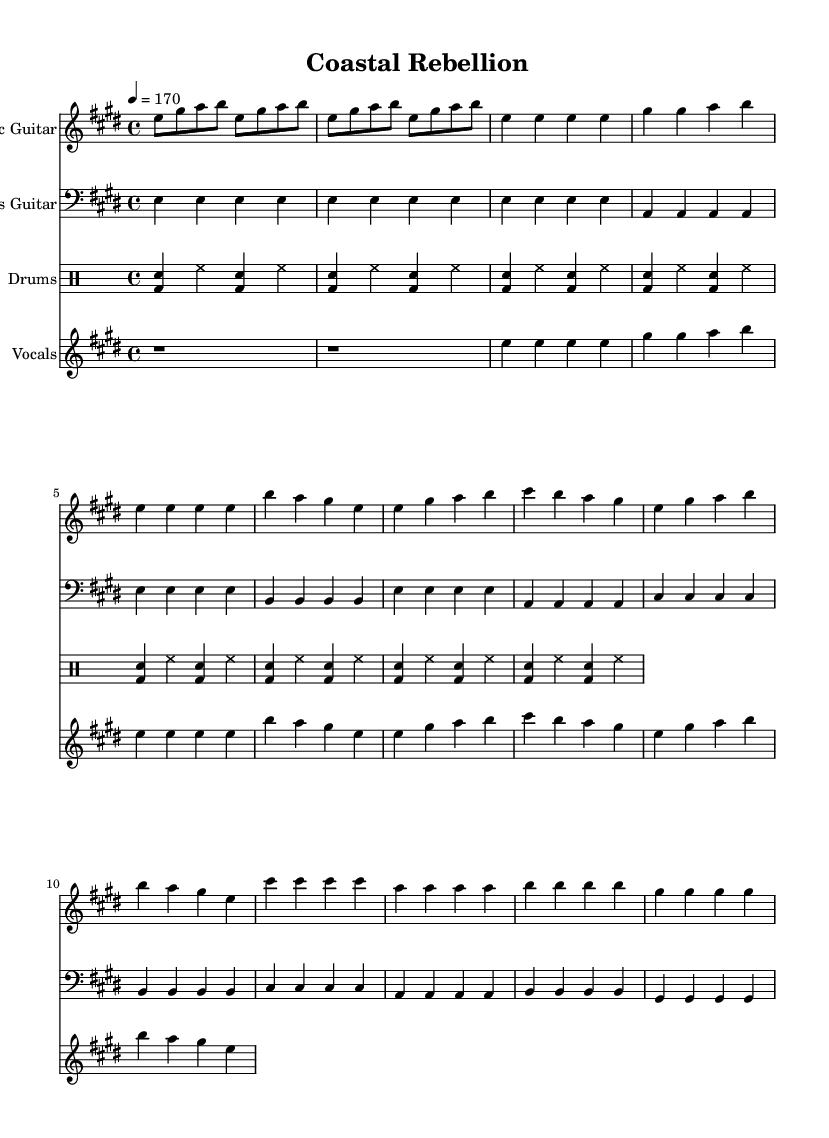What is the key signature of this music? The key signature is indicated at the beginning of the score. It is noted as having four sharps, which corresponds to E major.
Answer: E major What is the time signature of the piece? The time signature is shown at the beginning of the score as 4/4, which means four beats per measure, and each quarter note gets one beat.
Answer: 4/4 What is the tempo of the piece? The tempo is provided at the beginning of the score, indicating a speed of 170 beats per minute.
Answer: 170 How many sections are there in the music? By analyzing the score, we can see there are distinct sections labeled as "Intro," "Verse," "Chorus," and "Bridge." This shows that there are four main parts.
Answer: Four What instrument is featured as the lead in the arrangement? The title of the instrument is specified at the start of its staff in the score, labeling it clearly as "Electric Guitar."
Answer: Electric Guitar What type of rhythmic pattern does the drums part use? The drum part uses a basic punk beat pattern, characterized by the combination of bass drum and snare on the first and third beats, typical in punk music.
Answer: Punk beat What is the lyrical theme of the song? The lyrics indicate a theme focused on coastal adventures and the pursuit of freedom, as suggested by phrases like "Coastal winds are calling me" and "Chasing waves."
Answer: Coastal adventures 